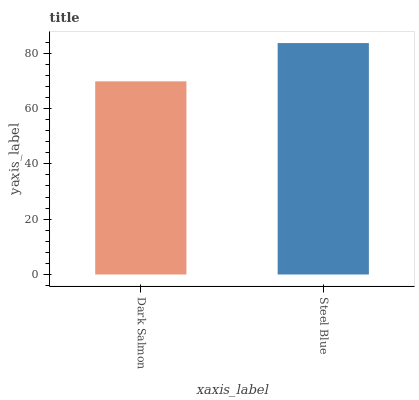Is Dark Salmon the minimum?
Answer yes or no. Yes. Is Steel Blue the maximum?
Answer yes or no. Yes. Is Steel Blue the minimum?
Answer yes or no. No. Is Steel Blue greater than Dark Salmon?
Answer yes or no. Yes. Is Dark Salmon less than Steel Blue?
Answer yes or no. Yes. Is Dark Salmon greater than Steel Blue?
Answer yes or no. No. Is Steel Blue less than Dark Salmon?
Answer yes or no. No. Is Steel Blue the high median?
Answer yes or no. Yes. Is Dark Salmon the low median?
Answer yes or no. Yes. Is Dark Salmon the high median?
Answer yes or no. No. Is Steel Blue the low median?
Answer yes or no. No. 